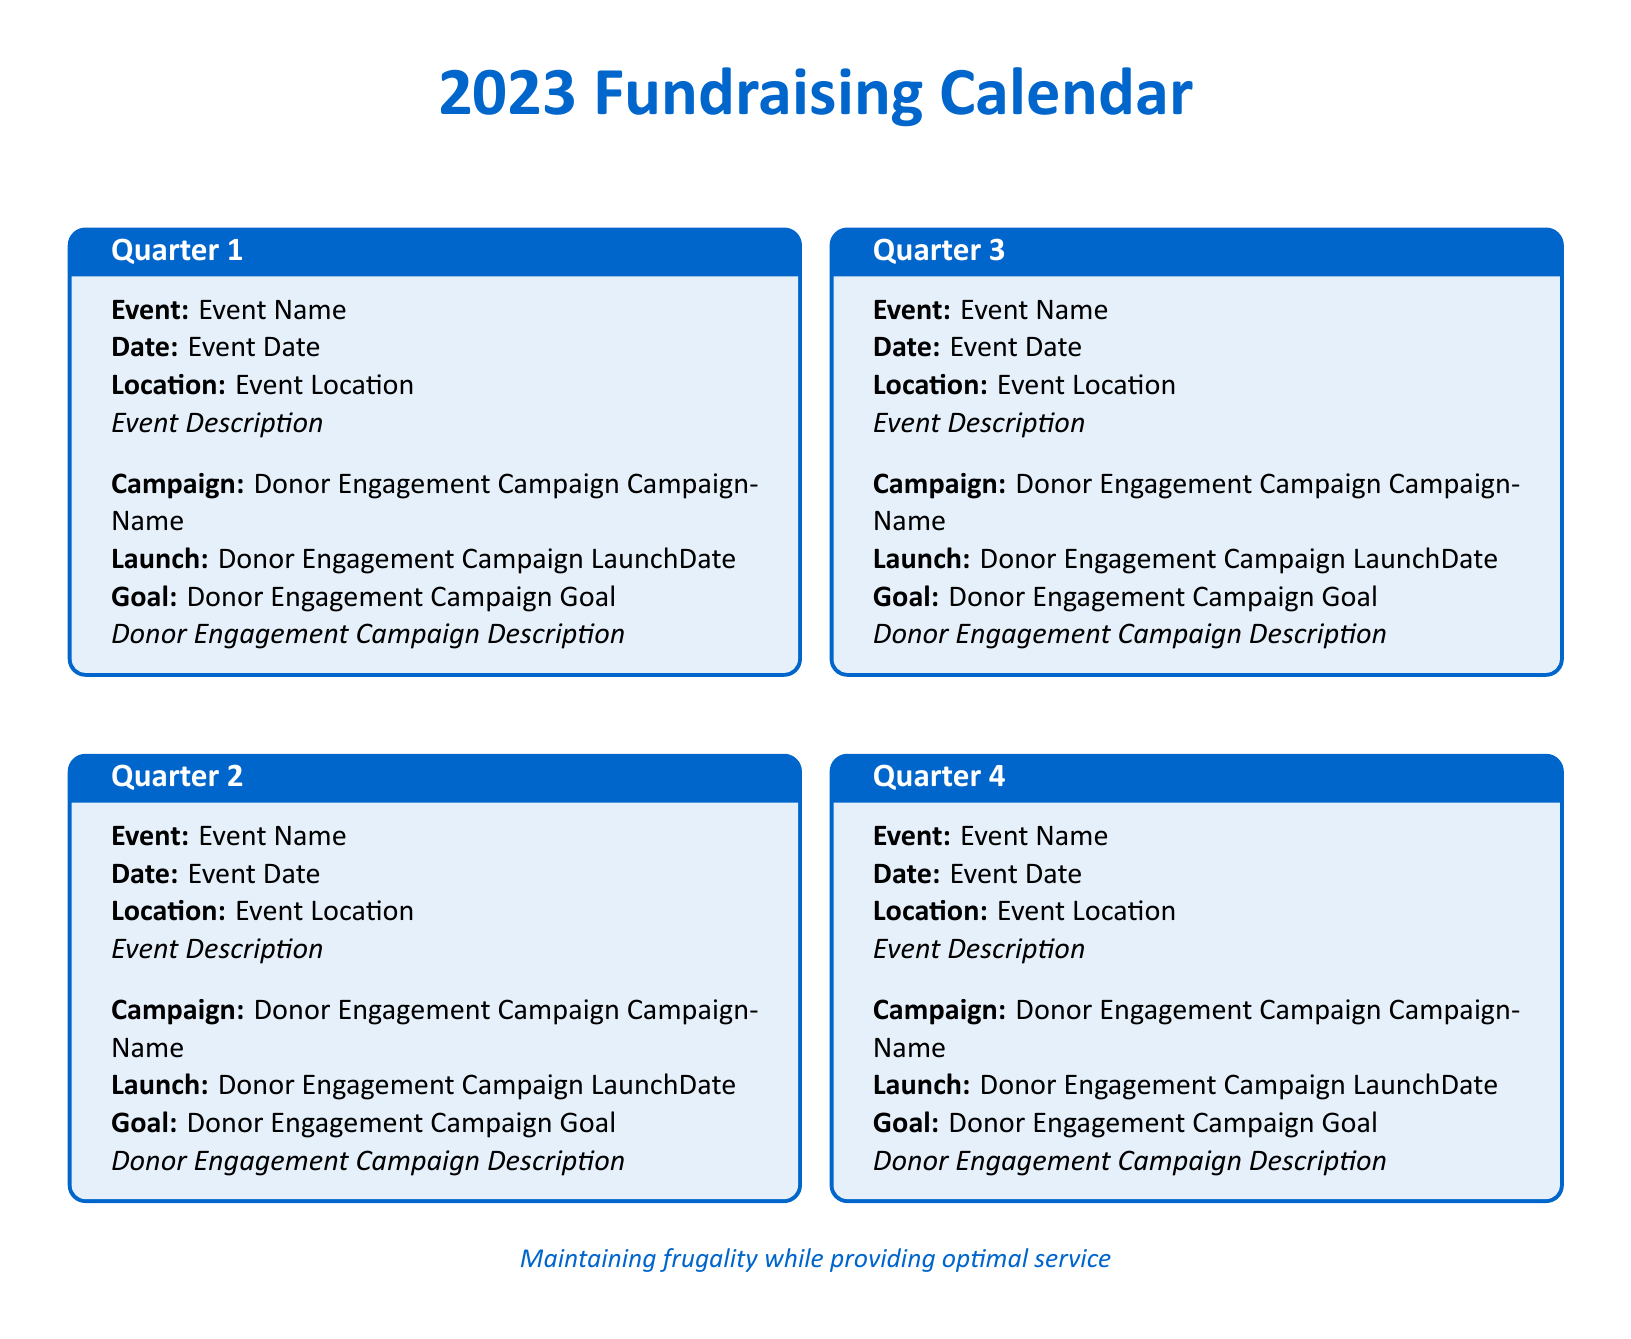what are the names of the events for quarter 1? The names of the events for each quarter can be found under the "Event:" section for each corresponding quarter.
Answer: Quarter 1 Event Name what is the date of the quarter 3 event? The date of the quarter 3 event is specified in the "Date:" section of quarter 3.
Answer: Quarter 3 Event Date what is the launch date of the donor engagement campaign in quarter 2? The launch date for the donor engagement campaign can be found in the "Launch:" section of quarter 2.
Answer: Quarter 2 Donor Engagement Campaign LaunchDate what is the goal of the donor engagement campaign for quarter 4? The goal for the donor engagement campaign is detailed in the "Goal:" section of quarter 4.
Answer: Quarter 4 Donor Engagement Campaign Goal how many quarters are listed in the document? The document contains a section for each quarter, and by counting these sections, you can determine the number of quarters.
Answer: 4 what is the theme emphasized in this calendar? The theme is stated at the bottom of the document, highlighting the focus of the organization.
Answer: Maintaining frugality while providing optimal service what type of event description is provided for quarter 1? The type of event description provided can be found in the "Description" section for quarter 1.
Answer: Quarter 1 Event Description which quarter has the earliest event date? To determine which has the earliest event date, compare the dates listed in the "Date:" section for all quarters.
Answer: Quarter 1 Event Date 